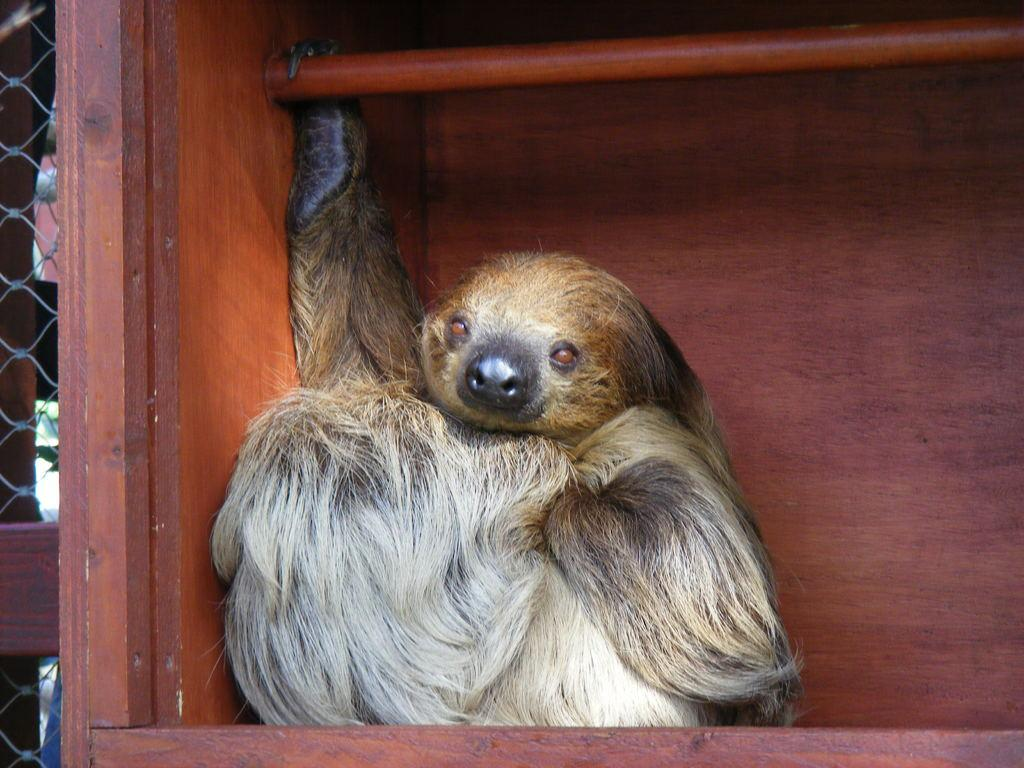What is inside the wooden object in the image? There is an animal in the wooden object. What can be seen on the left side of the image? There is a fence on the left side of the image. What type of government apparatus is depicted in the image? There is no government apparatus present in the image. What sign or symbol can be seen in the image? There is no sign or symbol present in the image. 